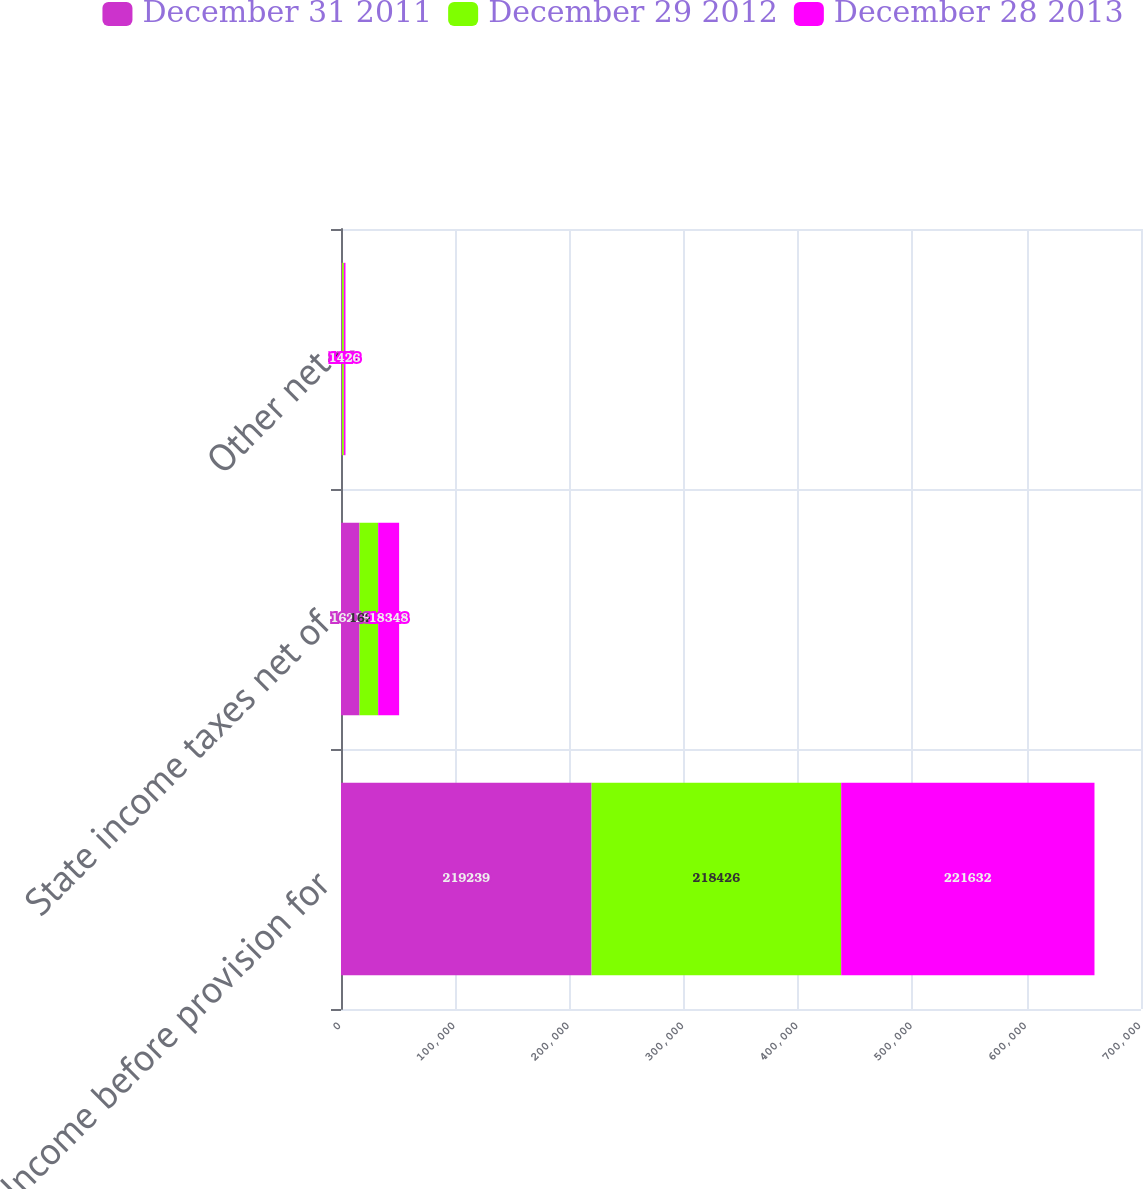Convert chart. <chart><loc_0><loc_0><loc_500><loc_500><stacked_bar_chart><ecel><fcel>Income before provision for<fcel>State income taxes net of<fcel>Other net<nl><fcel>December 31 2011<fcel>219239<fcel>16216<fcel>815<nl><fcel>December 29 2012<fcel>218426<fcel>16295<fcel>1683<nl><fcel>December 28 2013<fcel>221632<fcel>18348<fcel>1426<nl></chart> 